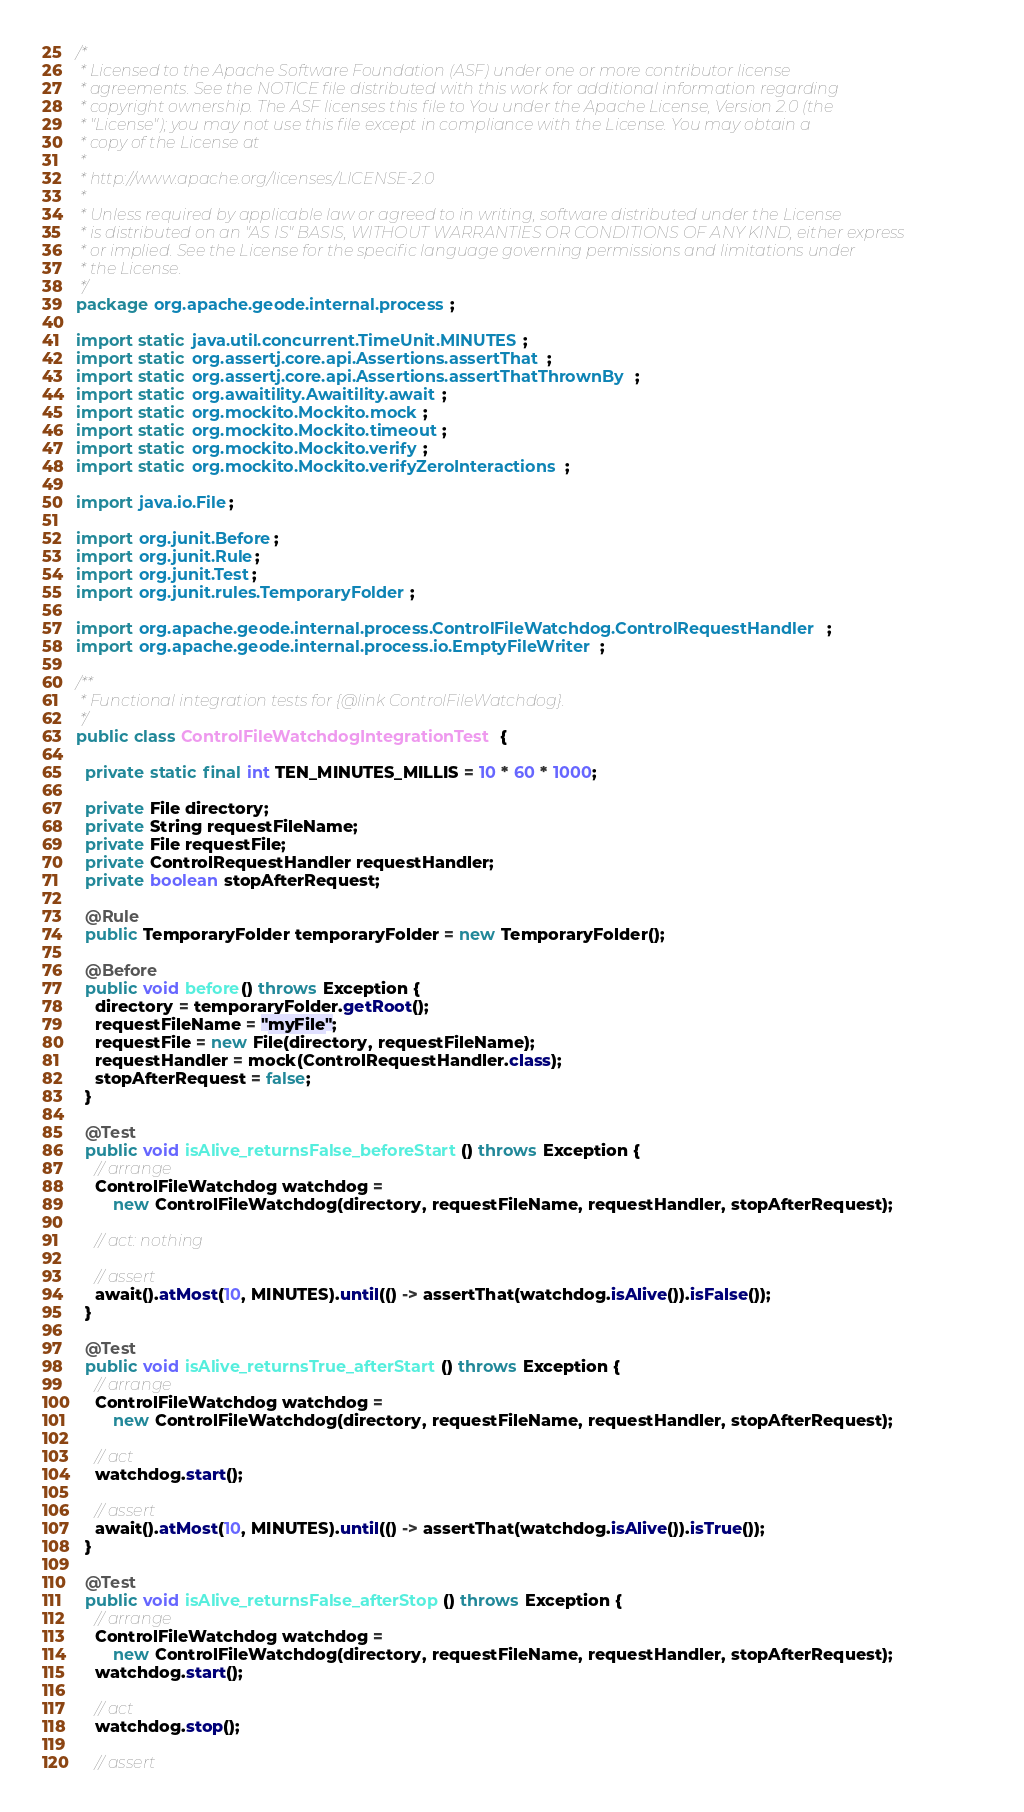Convert code to text. <code><loc_0><loc_0><loc_500><loc_500><_Java_>/*
 * Licensed to the Apache Software Foundation (ASF) under one or more contributor license
 * agreements. See the NOTICE file distributed with this work for additional information regarding
 * copyright ownership. The ASF licenses this file to You under the Apache License, Version 2.0 (the
 * "License"); you may not use this file except in compliance with the License. You may obtain a
 * copy of the License at
 *
 * http://www.apache.org/licenses/LICENSE-2.0
 *
 * Unless required by applicable law or agreed to in writing, software distributed under the License
 * is distributed on an "AS IS" BASIS, WITHOUT WARRANTIES OR CONDITIONS OF ANY KIND, either express
 * or implied. See the License for the specific language governing permissions and limitations under
 * the License.
 */
package org.apache.geode.internal.process;

import static java.util.concurrent.TimeUnit.MINUTES;
import static org.assertj.core.api.Assertions.assertThat;
import static org.assertj.core.api.Assertions.assertThatThrownBy;
import static org.awaitility.Awaitility.await;
import static org.mockito.Mockito.mock;
import static org.mockito.Mockito.timeout;
import static org.mockito.Mockito.verify;
import static org.mockito.Mockito.verifyZeroInteractions;

import java.io.File;

import org.junit.Before;
import org.junit.Rule;
import org.junit.Test;
import org.junit.rules.TemporaryFolder;

import org.apache.geode.internal.process.ControlFileWatchdog.ControlRequestHandler;
import org.apache.geode.internal.process.io.EmptyFileWriter;

/**
 * Functional integration tests for {@link ControlFileWatchdog}.
 */
public class ControlFileWatchdogIntegrationTest {

  private static final int TEN_MINUTES_MILLIS = 10 * 60 * 1000;

  private File directory;
  private String requestFileName;
  private File requestFile;
  private ControlRequestHandler requestHandler;
  private boolean stopAfterRequest;

  @Rule
  public TemporaryFolder temporaryFolder = new TemporaryFolder();

  @Before
  public void before() throws Exception {
    directory = temporaryFolder.getRoot();
    requestFileName = "myFile";
    requestFile = new File(directory, requestFileName);
    requestHandler = mock(ControlRequestHandler.class);
    stopAfterRequest = false;
  }

  @Test
  public void isAlive_returnsFalse_beforeStart() throws Exception {
    // arrange
    ControlFileWatchdog watchdog =
        new ControlFileWatchdog(directory, requestFileName, requestHandler, stopAfterRequest);

    // act: nothing

    // assert
    await().atMost(10, MINUTES).until(() -> assertThat(watchdog.isAlive()).isFalse());
  }

  @Test
  public void isAlive_returnsTrue_afterStart() throws Exception {
    // arrange
    ControlFileWatchdog watchdog =
        new ControlFileWatchdog(directory, requestFileName, requestHandler, stopAfterRequest);

    // act
    watchdog.start();

    // assert
    await().atMost(10, MINUTES).until(() -> assertThat(watchdog.isAlive()).isTrue());
  }

  @Test
  public void isAlive_returnsFalse_afterStop() throws Exception {
    // arrange
    ControlFileWatchdog watchdog =
        new ControlFileWatchdog(directory, requestFileName, requestHandler, stopAfterRequest);
    watchdog.start();

    // act
    watchdog.stop();

    // assert</code> 